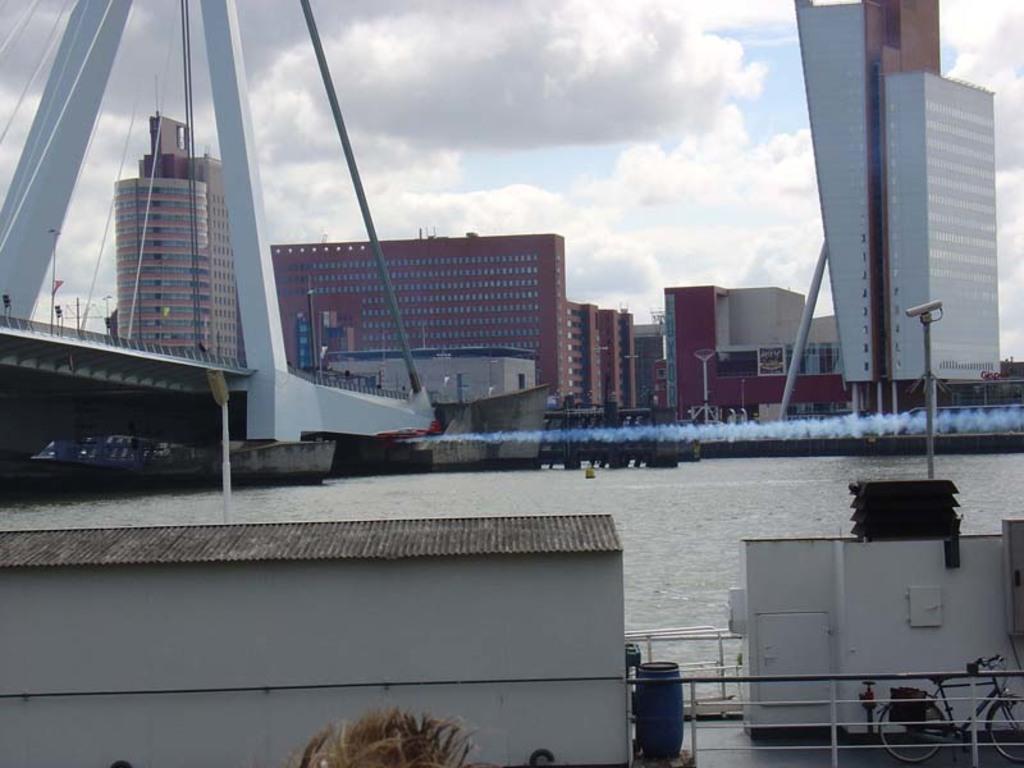Could you give a brief overview of what you see in this image? In this picture I can see there is a river and there are some buildings and there is a bridge here on the left and the sky is clear. 